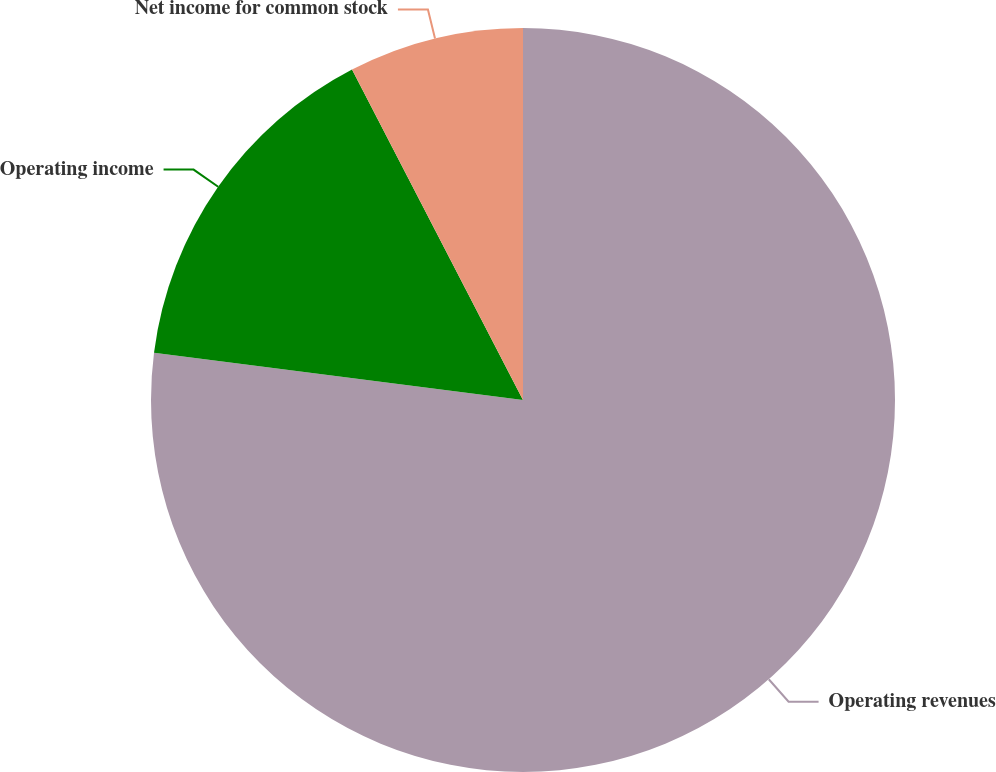Convert chart to OTSL. <chart><loc_0><loc_0><loc_500><loc_500><pie_chart><fcel>Operating revenues<fcel>Operating income<fcel>Net income for common stock<nl><fcel>77.02%<fcel>15.37%<fcel>7.6%<nl></chart> 